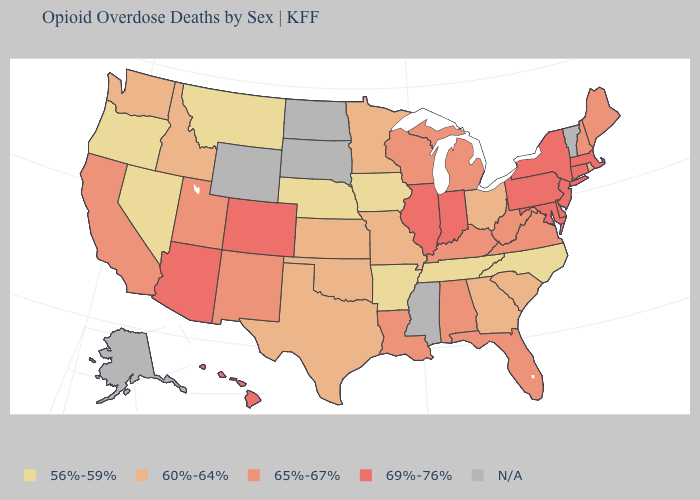Does Tennessee have the lowest value in the USA?
Quick response, please. Yes. What is the value of Kansas?
Keep it brief. 60%-64%. What is the value of Oklahoma?
Concise answer only. 60%-64%. What is the value of Virginia?
Keep it brief. 65%-67%. Among the states that border Oklahoma , which have the lowest value?
Concise answer only. Arkansas. Name the states that have a value in the range 60%-64%?
Quick response, please. Georgia, Idaho, Kansas, Minnesota, Missouri, Ohio, Oklahoma, Rhode Island, South Carolina, Texas, Washington. Is the legend a continuous bar?
Write a very short answer. No. Among the states that border Michigan , does Ohio have the highest value?
Keep it brief. No. What is the value of Mississippi?
Keep it brief. N/A. Name the states that have a value in the range 60%-64%?
Quick response, please. Georgia, Idaho, Kansas, Minnesota, Missouri, Ohio, Oklahoma, Rhode Island, South Carolina, Texas, Washington. What is the value of New Hampshire?
Write a very short answer. 65%-67%. Does Illinois have the highest value in the USA?
Keep it brief. Yes. What is the value of Maine?
Give a very brief answer. 65%-67%. Which states have the highest value in the USA?
Write a very short answer. Arizona, Colorado, Connecticut, Delaware, Hawaii, Illinois, Indiana, Maryland, Massachusetts, New Jersey, New York, Pennsylvania. 